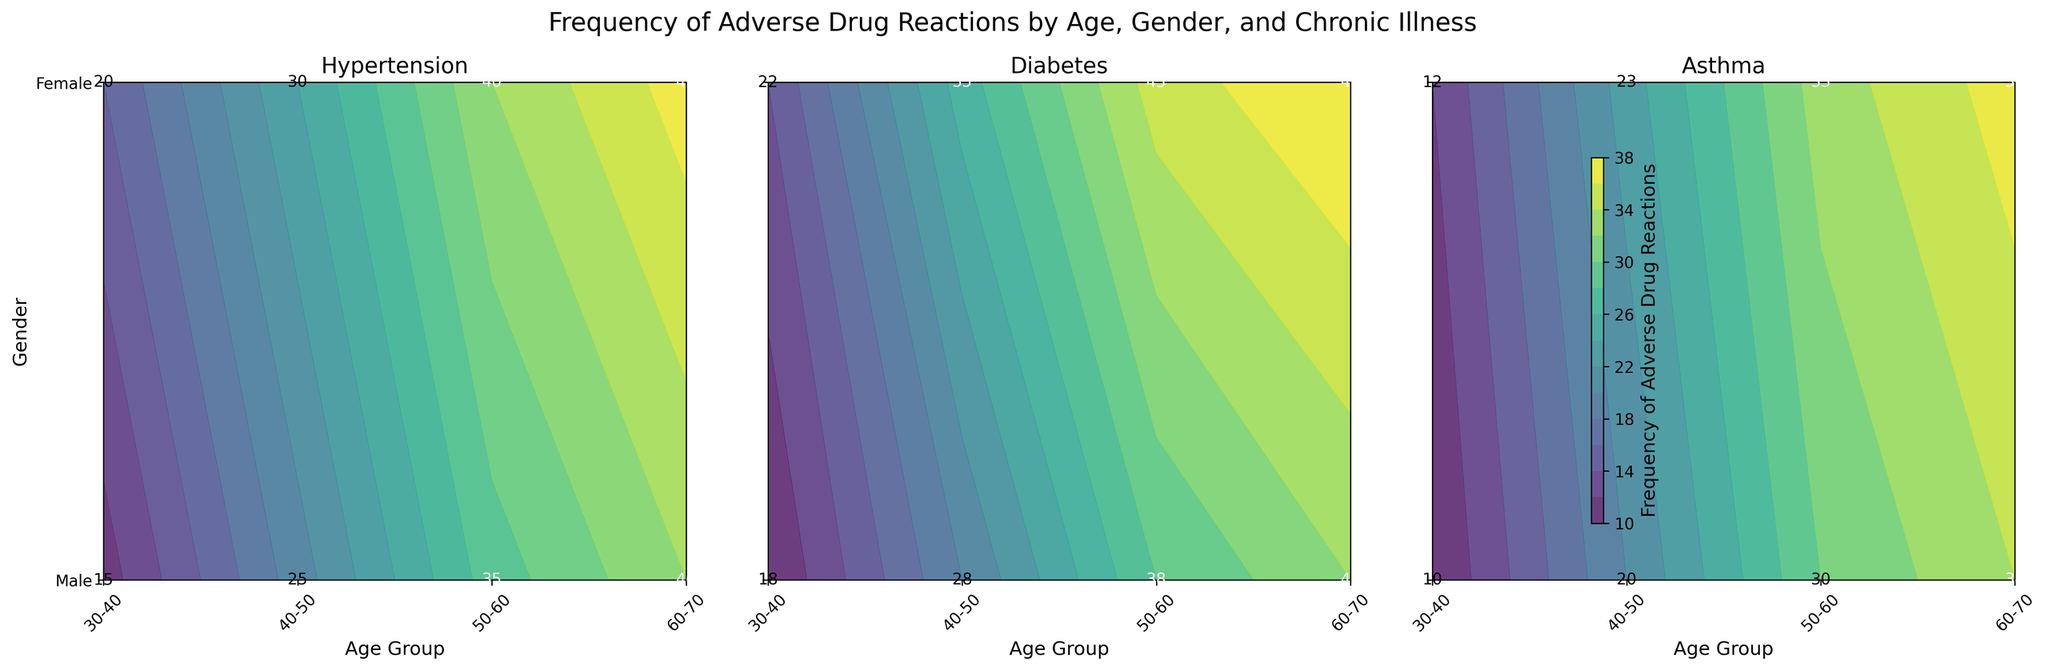What is the title of the figure? The title is usually located at the top of the figure. It provides a brief description of what the figure represents. Here, it reads "Frequency of Adverse Drug Reactions by Age, Gender, and Chronic Illness."
Answer: Frequency of Adverse Drug Reactions by Age, Gender, and Chronic Illness Which chronic illness shows the highest frequency of adverse drug reactions for females in the 40-50 age group? Look at the subplot for each chronic illness and find the value for females in the 40-50 age group. Hypertension has a value of 30, Diabetes has 35, and Asthma has 23. Among these, Diabetes has the highest value.
Answer: Diabetes What is the range of frequencies for adverse drug reactions shown on the color bar? The range can be identified by looking at the spectrum of colors on the color bar and noting the minimum and maximum values indicated.
Answer: 10 to 48 Which gender shows a higher frequency of adverse drug reactions for the age group 50-60 with Hypertension? In the Hypertension subplot, compare the frequency values for males and females in the 50-60 age group. Males have a frequency of 35, and females have 40.
Answer: Females What can be inferred about the trend of adverse drug reactions by age across all chronic illnesses for both genders? Observe the overall pattern in the subplots. The frequency of adverse drug reactions appears to increase with age for both genders across all chronic illnesses. The values generally go up from the 30-40 age group to the 60-70 age group.
Answer: Frequency increases with age Comparing Hypertension and Diabetes, which illness shows more variability in adverse drug reactions across different age groups for females? Look at the variability of the frequency values across different age groups for females in the Hypertension and Diabetes subplots. Hypertension ranges from 20 to 45 while Diabetes ranges from 22 to 48.
Answer: Diabetes In which age group does the male with Asthma have the lowest frequency of adverse drug reactions, and what is that frequency? In the Asthma subplot, check the value for males across all age groups and identify the lowest one. The lowest value is 10 in the 30-40 age group.
Answer: 30-40, 10 What is the average frequency of adverse drug reactions for males with Asthma across all age groups? For males with Asthma, the frequencies are 10, 20, 30, and 34. The average can be calculated as (10 + 20 + 30 + 34) / 4 = 23.5.
Answer: 23.5 How does the frequency of adverse drug reactions for females with Diabetes in the 60-70 age group compare to females with Hypertension in the same age group? Compare the values for females in the 60-70 age group in the Diabetes and Hypertension subplots. Diabetes has a frequency of 48, while Hypertension has 45. Diabetes shows a higher frequency.
Answer: Diabetes is higher 